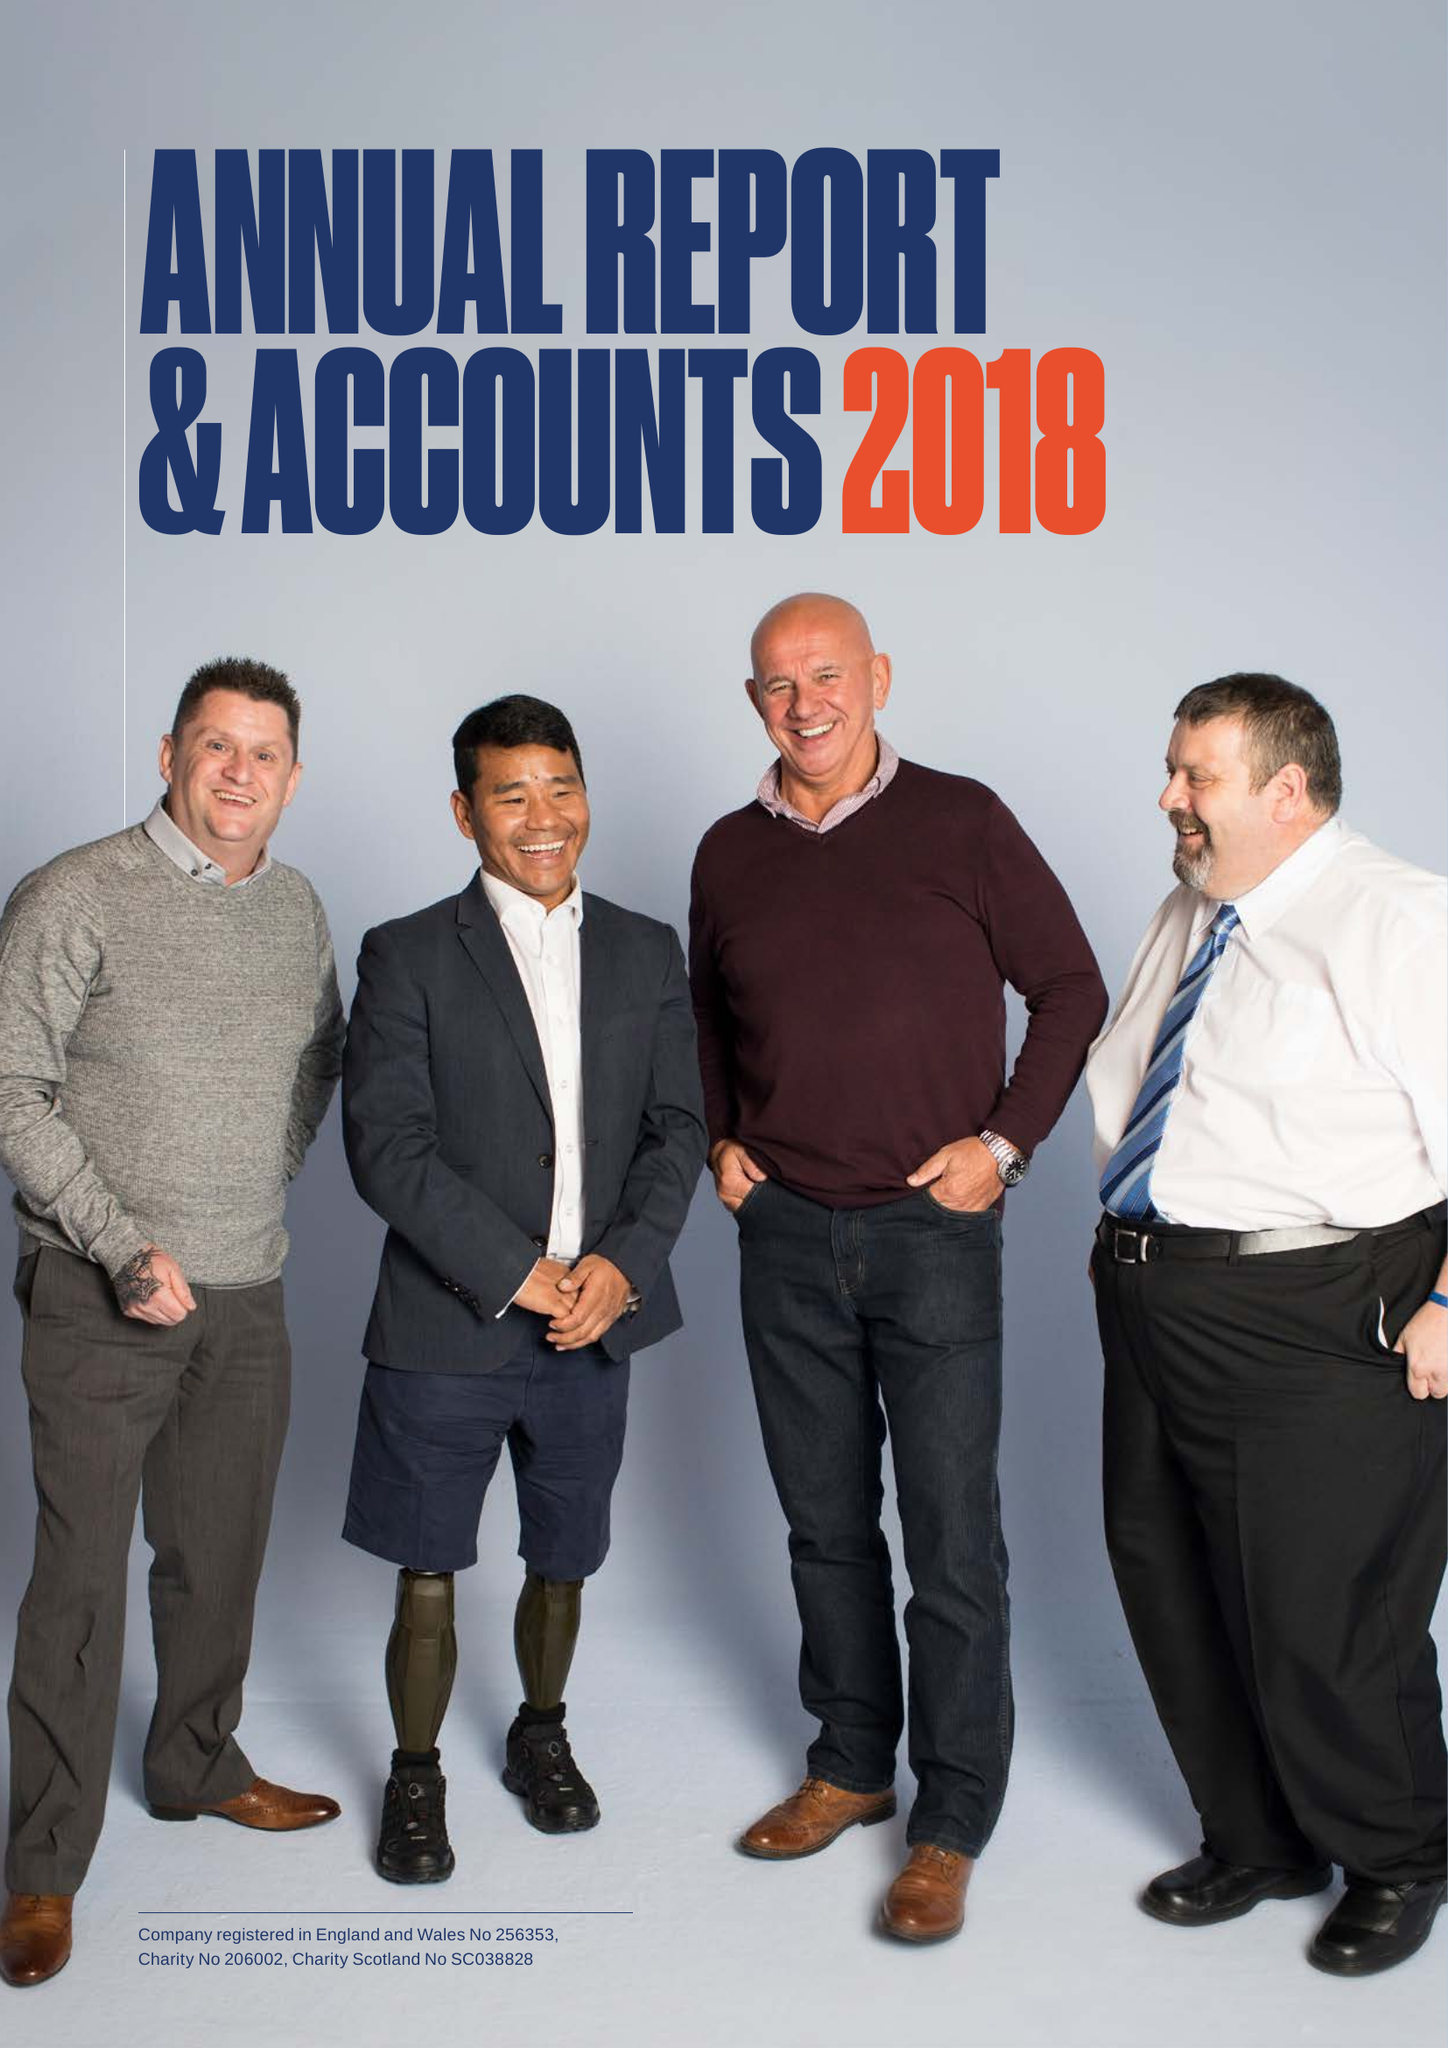What is the value for the income_annually_in_british_pounds?
Answer the question using a single word or phrase. 15774000.00 